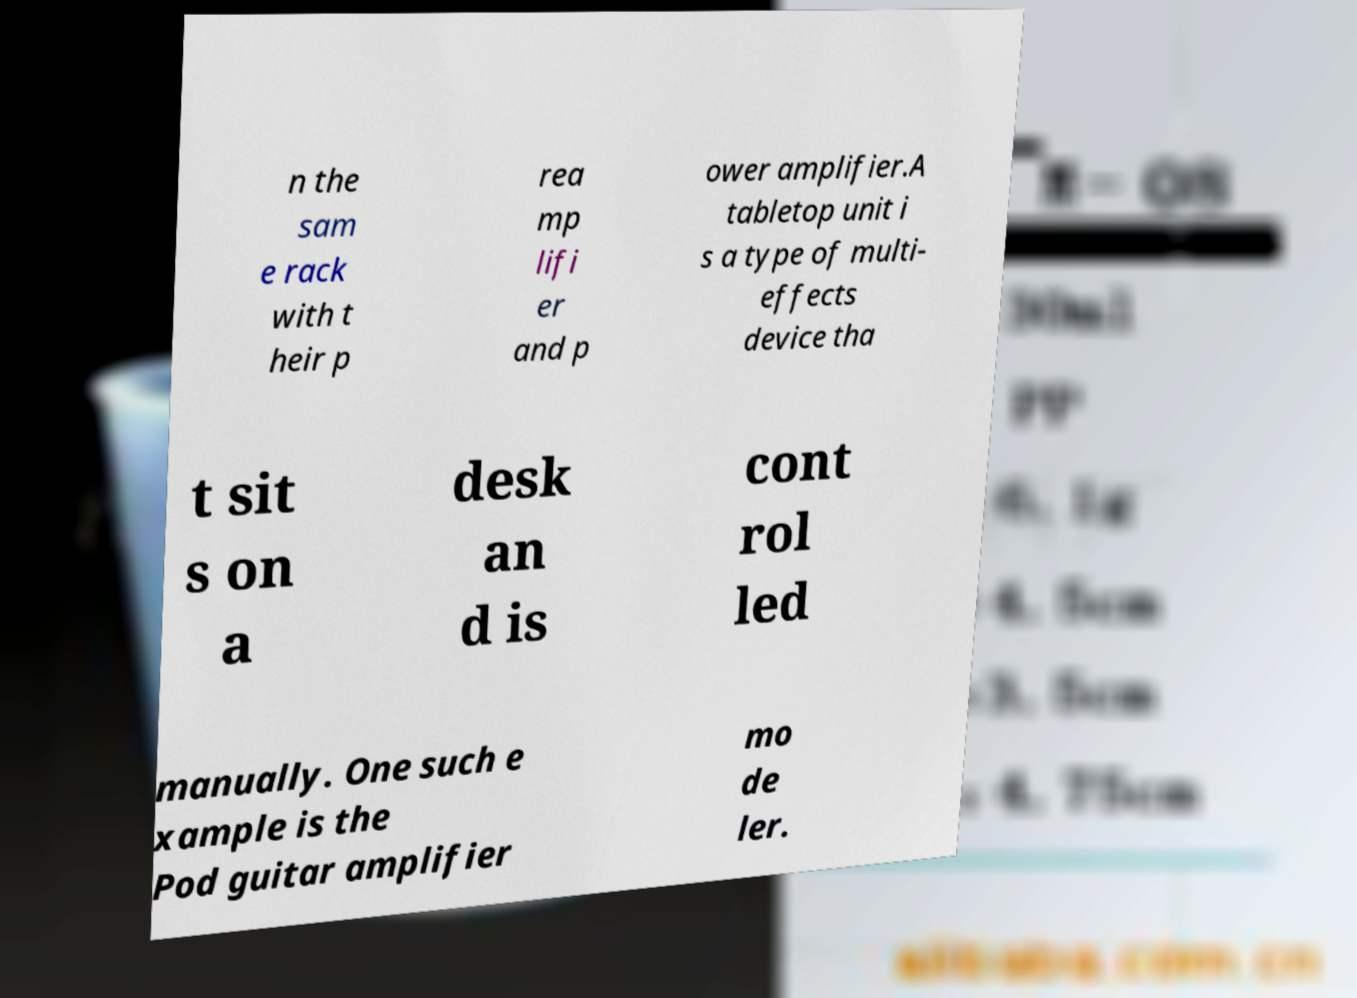Could you assist in decoding the text presented in this image and type it out clearly? n the sam e rack with t heir p rea mp lifi er and p ower amplifier.A tabletop unit i s a type of multi- effects device tha t sit s on a desk an d is cont rol led manually. One such e xample is the Pod guitar amplifier mo de ler. 